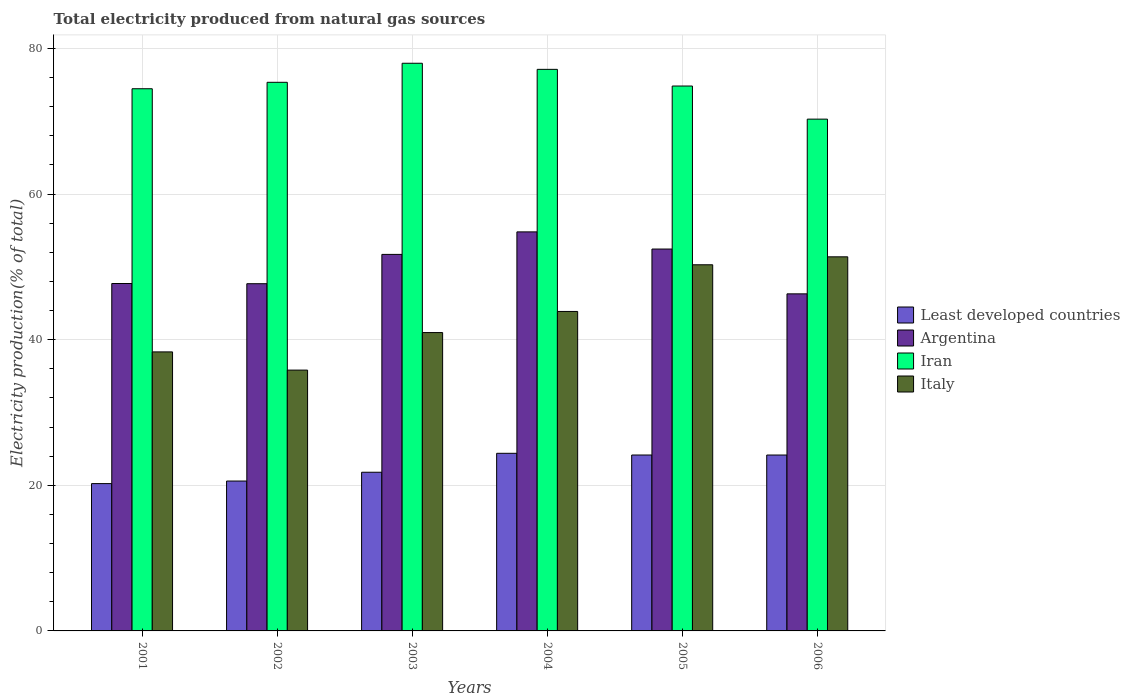How many different coloured bars are there?
Your answer should be very brief. 4. How many groups of bars are there?
Your answer should be compact. 6. What is the label of the 6th group of bars from the left?
Offer a very short reply. 2006. In how many cases, is the number of bars for a given year not equal to the number of legend labels?
Offer a very short reply. 0. What is the total electricity produced in Iran in 2003?
Provide a short and direct response. 77.96. Across all years, what is the maximum total electricity produced in Iran?
Offer a terse response. 77.96. Across all years, what is the minimum total electricity produced in Italy?
Your answer should be very brief. 35.82. In which year was the total electricity produced in Italy maximum?
Offer a terse response. 2006. What is the total total electricity produced in Argentina in the graph?
Offer a very short reply. 300.64. What is the difference between the total electricity produced in Argentina in 2002 and that in 2004?
Provide a short and direct response. -7.12. What is the difference between the total electricity produced in Least developed countries in 2005 and the total electricity produced in Iran in 2004?
Your response must be concise. -52.97. What is the average total electricity produced in Iran per year?
Ensure brevity in your answer.  75. In the year 2005, what is the difference between the total electricity produced in Italy and total electricity produced in Iran?
Offer a very short reply. -24.55. In how many years, is the total electricity produced in Iran greater than 64 %?
Your answer should be very brief. 6. What is the ratio of the total electricity produced in Argentina in 2003 to that in 2004?
Offer a terse response. 0.94. Is the total electricity produced in Least developed countries in 2002 less than that in 2005?
Make the answer very short. Yes. What is the difference between the highest and the second highest total electricity produced in Least developed countries?
Offer a very short reply. 0.23. What is the difference between the highest and the lowest total electricity produced in Argentina?
Give a very brief answer. 8.51. What does the 2nd bar from the left in 2002 represents?
Your answer should be compact. Argentina. What does the 4th bar from the right in 2006 represents?
Provide a succinct answer. Least developed countries. Is it the case that in every year, the sum of the total electricity produced in Argentina and total electricity produced in Italy is greater than the total electricity produced in Iran?
Offer a terse response. Yes. How many years are there in the graph?
Ensure brevity in your answer.  6. Are the values on the major ticks of Y-axis written in scientific E-notation?
Your response must be concise. No. Where does the legend appear in the graph?
Provide a succinct answer. Center right. What is the title of the graph?
Ensure brevity in your answer.  Total electricity produced from natural gas sources. Does "Benin" appear as one of the legend labels in the graph?
Keep it short and to the point. No. What is the Electricity production(% of total) in Least developed countries in 2001?
Your response must be concise. 20.23. What is the Electricity production(% of total) of Argentina in 2001?
Your response must be concise. 47.71. What is the Electricity production(% of total) of Iran in 2001?
Make the answer very short. 74.46. What is the Electricity production(% of total) in Italy in 2001?
Keep it short and to the point. 38.32. What is the Electricity production(% of total) in Least developed countries in 2002?
Make the answer very short. 20.58. What is the Electricity production(% of total) in Argentina in 2002?
Offer a very short reply. 47.68. What is the Electricity production(% of total) in Iran in 2002?
Your answer should be very brief. 75.34. What is the Electricity production(% of total) in Italy in 2002?
Make the answer very short. 35.82. What is the Electricity production(% of total) in Least developed countries in 2003?
Provide a short and direct response. 21.79. What is the Electricity production(% of total) in Argentina in 2003?
Provide a succinct answer. 51.71. What is the Electricity production(% of total) in Iran in 2003?
Provide a succinct answer. 77.96. What is the Electricity production(% of total) in Italy in 2003?
Your response must be concise. 40.97. What is the Electricity production(% of total) of Least developed countries in 2004?
Your answer should be compact. 24.39. What is the Electricity production(% of total) in Argentina in 2004?
Offer a terse response. 54.8. What is the Electricity production(% of total) of Iran in 2004?
Make the answer very short. 77.12. What is the Electricity production(% of total) in Italy in 2004?
Make the answer very short. 43.87. What is the Electricity production(% of total) in Least developed countries in 2005?
Offer a very short reply. 24.16. What is the Electricity production(% of total) in Argentina in 2005?
Provide a succinct answer. 52.45. What is the Electricity production(% of total) in Iran in 2005?
Ensure brevity in your answer.  74.83. What is the Electricity production(% of total) of Italy in 2005?
Offer a terse response. 50.28. What is the Electricity production(% of total) of Least developed countries in 2006?
Your response must be concise. 24.16. What is the Electricity production(% of total) in Argentina in 2006?
Provide a succinct answer. 46.29. What is the Electricity production(% of total) of Iran in 2006?
Offer a very short reply. 70.29. What is the Electricity production(% of total) in Italy in 2006?
Provide a short and direct response. 51.38. Across all years, what is the maximum Electricity production(% of total) of Least developed countries?
Provide a short and direct response. 24.39. Across all years, what is the maximum Electricity production(% of total) in Argentina?
Provide a short and direct response. 54.8. Across all years, what is the maximum Electricity production(% of total) of Iran?
Keep it short and to the point. 77.96. Across all years, what is the maximum Electricity production(% of total) of Italy?
Make the answer very short. 51.38. Across all years, what is the minimum Electricity production(% of total) in Least developed countries?
Your response must be concise. 20.23. Across all years, what is the minimum Electricity production(% of total) in Argentina?
Ensure brevity in your answer.  46.29. Across all years, what is the minimum Electricity production(% of total) of Iran?
Give a very brief answer. 70.29. Across all years, what is the minimum Electricity production(% of total) of Italy?
Your answer should be compact. 35.82. What is the total Electricity production(% of total) in Least developed countries in the graph?
Ensure brevity in your answer.  135.31. What is the total Electricity production(% of total) in Argentina in the graph?
Provide a succinct answer. 300.64. What is the total Electricity production(% of total) in Iran in the graph?
Make the answer very short. 450. What is the total Electricity production(% of total) of Italy in the graph?
Keep it short and to the point. 260.65. What is the difference between the Electricity production(% of total) in Least developed countries in 2001 and that in 2002?
Your answer should be very brief. -0.35. What is the difference between the Electricity production(% of total) in Argentina in 2001 and that in 2002?
Your response must be concise. 0.03. What is the difference between the Electricity production(% of total) in Iran in 2001 and that in 2002?
Offer a terse response. -0.88. What is the difference between the Electricity production(% of total) in Italy in 2001 and that in 2002?
Your response must be concise. 2.5. What is the difference between the Electricity production(% of total) in Least developed countries in 2001 and that in 2003?
Offer a very short reply. -1.56. What is the difference between the Electricity production(% of total) in Argentina in 2001 and that in 2003?
Make the answer very short. -4. What is the difference between the Electricity production(% of total) in Iran in 2001 and that in 2003?
Your response must be concise. -3.5. What is the difference between the Electricity production(% of total) of Italy in 2001 and that in 2003?
Give a very brief answer. -2.65. What is the difference between the Electricity production(% of total) of Least developed countries in 2001 and that in 2004?
Keep it short and to the point. -4.16. What is the difference between the Electricity production(% of total) in Argentina in 2001 and that in 2004?
Provide a succinct answer. -7.09. What is the difference between the Electricity production(% of total) in Iran in 2001 and that in 2004?
Ensure brevity in your answer.  -2.66. What is the difference between the Electricity production(% of total) in Italy in 2001 and that in 2004?
Provide a succinct answer. -5.56. What is the difference between the Electricity production(% of total) in Least developed countries in 2001 and that in 2005?
Give a very brief answer. -3.93. What is the difference between the Electricity production(% of total) in Argentina in 2001 and that in 2005?
Offer a very short reply. -4.73. What is the difference between the Electricity production(% of total) of Iran in 2001 and that in 2005?
Your answer should be very brief. -0.37. What is the difference between the Electricity production(% of total) of Italy in 2001 and that in 2005?
Offer a terse response. -11.96. What is the difference between the Electricity production(% of total) of Least developed countries in 2001 and that in 2006?
Offer a terse response. -3.93. What is the difference between the Electricity production(% of total) in Argentina in 2001 and that in 2006?
Keep it short and to the point. 1.42. What is the difference between the Electricity production(% of total) of Iran in 2001 and that in 2006?
Your answer should be very brief. 4.17. What is the difference between the Electricity production(% of total) in Italy in 2001 and that in 2006?
Make the answer very short. -13.06. What is the difference between the Electricity production(% of total) of Least developed countries in 2002 and that in 2003?
Make the answer very short. -1.21. What is the difference between the Electricity production(% of total) in Argentina in 2002 and that in 2003?
Give a very brief answer. -4.03. What is the difference between the Electricity production(% of total) in Iran in 2002 and that in 2003?
Your answer should be compact. -2.62. What is the difference between the Electricity production(% of total) in Italy in 2002 and that in 2003?
Your answer should be compact. -5.15. What is the difference between the Electricity production(% of total) of Least developed countries in 2002 and that in 2004?
Provide a short and direct response. -3.81. What is the difference between the Electricity production(% of total) of Argentina in 2002 and that in 2004?
Provide a short and direct response. -7.12. What is the difference between the Electricity production(% of total) of Iran in 2002 and that in 2004?
Your answer should be very brief. -1.78. What is the difference between the Electricity production(% of total) in Italy in 2002 and that in 2004?
Make the answer very short. -8.05. What is the difference between the Electricity production(% of total) in Least developed countries in 2002 and that in 2005?
Provide a short and direct response. -3.57. What is the difference between the Electricity production(% of total) in Argentina in 2002 and that in 2005?
Keep it short and to the point. -4.76. What is the difference between the Electricity production(% of total) of Iran in 2002 and that in 2005?
Give a very brief answer. 0.51. What is the difference between the Electricity production(% of total) of Italy in 2002 and that in 2005?
Your answer should be very brief. -14.46. What is the difference between the Electricity production(% of total) of Least developed countries in 2002 and that in 2006?
Give a very brief answer. -3.57. What is the difference between the Electricity production(% of total) in Argentina in 2002 and that in 2006?
Keep it short and to the point. 1.39. What is the difference between the Electricity production(% of total) of Iran in 2002 and that in 2006?
Provide a short and direct response. 5.06. What is the difference between the Electricity production(% of total) in Italy in 2002 and that in 2006?
Your response must be concise. -15.56. What is the difference between the Electricity production(% of total) of Least developed countries in 2003 and that in 2004?
Make the answer very short. -2.6. What is the difference between the Electricity production(% of total) in Argentina in 2003 and that in 2004?
Keep it short and to the point. -3.09. What is the difference between the Electricity production(% of total) in Iran in 2003 and that in 2004?
Your answer should be compact. 0.84. What is the difference between the Electricity production(% of total) of Italy in 2003 and that in 2004?
Offer a very short reply. -2.9. What is the difference between the Electricity production(% of total) in Least developed countries in 2003 and that in 2005?
Offer a terse response. -2.37. What is the difference between the Electricity production(% of total) of Argentina in 2003 and that in 2005?
Your answer should be compact. -0.74. What is the difference between the Electricity production(% of total) in Iran in 2003 and that in 2005?
Your answer should be very brief. 3.13. What is the difference between the Electricity production(% of total) in Italy in 2003 and that in 2005?
Your response must be concise. -9.31. What is the difference between the Electricity production(% of total) of Least developed countries in 2003 and that in 2006?
Provide a succinct answer. -2.37. What is the difference between the Electricity production(% of total) of Argentina in 2003 and that in 2006?
Provide a succinct answer. 5.42. What is the difference between the Electricity production(% of total) of Iran in 2003 and that in 2006?
Offer a very short reply. 7.67. What is the difference between the Electricity production(% of total) in Italy in 2003 and that in 2006?
Provide a succinct answer. -10.4. What is the difference between the Electricity production(% of total) in Least developed countries in 2004 and that in 2005?
Your response must be concise. 0.23. What is the difference between the Electricity production(% of total) in Argentina in 2004 and that in 2005?
Keep it short and to the point. 2.36. What is the difference between the Electricity production(% of total) of Iran in 2004 and that in 2005?
Provide a succinct answer. 2.29. What is the difference between the Electricity production(% of total) of Italy in 2004 and that in 2005?
Provide a short and direct response. -6.41. What is the difference between the Electricity production(% of total) in Least developed countries in 2004 and that in 2006?
Offer a terse response. 0.24. What is the difference between the Electricity production(% of total) of Argentina in 2004 and that in 2006?
Offer a terse response. 8.51. What is the difference between the Electricity production(% of total) of Iran in 2004 and that in 2006?
Your response must be concise. 6.84. What is the difference between the Electricity production(% of total) in Italy in 2004 and that in 2006?
Make the answer very short. -7.5. What is the difference between the Electricity production(% of total) in Least developed countries in 2005 and that in 2006?
Provide a succinct answer. 0. What is the difference between the Electricity production(% of total) of Argentina in 2005 and that in 2006?
Your response must be concise. 6.16. What is the difference between the Electricity production(% of total) in Iran in 2005 and that in 2006?
Your answer should be compact. 4.55. What is the difference between the Electricity production(% of total) in Italy in 2005 and that in 2006?
Give a very brief answer. -1.09. What is the difference between the Electricity production(% of total) in Least developed countries in 2001 and the Electricity production(% of total) in Argentina in 2002?
Your answer should be compact. -27.45. What is the difference between the Electricity production(% of total) of Least developed countries in 2001 and the Electricity production(% of total) of Iran in 2002?
Ensure brevity in your answer.  -55.11. What is the difference between the Electricity production(% of total) of Least developed countries in 2001 and the Electricity production(% of total) of Italy in 2002?
Make the answer very short. -15.59. What is the difference between the Electricity production(% of total) in Argentina in 2001 and the Electricity production(% of total) in Iran in 2002?
Your answer should be very brief. -27.63. What is the difference between the Electricity production(% of total) of Argentina in 2001 and the Electricity production(% of total) of Italy in 2002?
Your answer should be compact. 11.89. What is the difference between the Electricity production(% of total) in Iran in 2001 and the Electricity production(% of total) in Italy in 2002?
Provide a succinct answer. 38.64. What is the difference between the Electricity production(% of total) in Least developed countries in 2001 and the Electricity production(% of total) in Argentina in 2003?
Make the answer very short. -31.48. What is the difference between the Electricity production(% of total) of Least developed countries in 2001 and the Electricity production(% of total) of Iran in 2003?
Provide a succinct answer. -57.73. What is the difference between the Electricity production(% of total) in Least developed countries in 2001 and the Electricity production(% of total) in Italy in 2003?
Ensure brevity in your answer.  -20.74. What is the difference between the Electricity production(% of total) in Argentina in 2001 and the Electricity production(% of total) in Iran in 2003?
Ensure brevity in your answer.  -30.25. What is the difference between the Electricity production(% of total) of Argentina in 2001 and the Electricity production(% of total) of Italy in 2003?
Offer a terse response. 6.74. What is the difference between the Electricity production(% of total) in Iran in 2001 and the Electricity production(% of total) in Italy in 2003?
Make the answer very short. 33.49. What is the difference between the Electricity production(% of total) of Least developed countries in 2001 and the Electricity production(% of total) of Argentina in 2004?
Provide a succinct answer. -34.57. What is the difference between the Electricity production(% of total) in Least developed countries in 2001 and the Electricity production(% of total) in Iran in 2004?
Offer a terse response. -56.89. What is the difference between the Electricity production(% of total) of Least developed countries in 2001 and the Electricity production(% of total) of Italy in 2004?
Your response must be concise. -23.64. What is the difference between the Electricity production(% of total) of Argentina in 2001 and the Electricity production(% of total) of Iran in 2004?
Keep it short and to the point. -29.41. What is the difference between the Electricity production(% of total) in Argentina in 2001 and the Electricity production(% of total) in Italy in 2004?
Your answer should be very brief. 3.84. What is the difference between the Electricity production(% of total) in Iran in 2001 and the Electricity production(% of total) in Italy in 2004?
Provide a short and direct response. 30.58. What is the difference between the Electricity production(% of total) in Least developed countries in 2001 and the Electricity production(% of total) in Argentina in 2005?
Provide a short and direct response. -32.21. What is the difference between the Electricity production(% of total) of Least developed countries in 2001 and the Electricity production(% of total) of Iran in 2005?
Your answer should be compact. -54.6. What is the difference between the Electricity production(% of total) in Least developed countries in 2001 and the Electricity production(% of total) in Italy in 2005?
Offer a terse response. -30.05. What is the difference between the Electricity production(% of total) of Argentina in 2001 and the Electricity production(% of total) of Iran in 2005?
Your answer should be very brief. -27.12. What is the difference between the Electricity production(% of total) in Argentina in 2001 and the Electricity production(% of total) in Italy in 2005?
Offer a terse response. -2.57. What is the difference between the Electricity production(% of total) in Iran in 2001 and the Electricity production(% of total) in Italy in 2005?
Make the answer very short. 24.18. What is the difference between the Electricity production(% of total) in Least developed countries in 2001 and the Electricity production(% of total) in Argentina in 2006?
Offer a very short reply. -26.06. What is the difference between the Electricity production(% of total) of Least developed countries in 2001 and the Electricity production(% of total) of Iran in 2006?
Your answer should be very brief. -50.05. What is the difference between the Electricity production(% of total) of Least developed countries in 2001 and the Electricity production(% of total) of Italy in 2006?
Offer a very short reply. -31.14. What is the difference between the Electricity production(% of total) in Argentina in 2001 and the Electricity production(% of total) in Iran in 2006?
Offer a terse response. -22.57. What is the difference between the Electricity production(% of total) of Argentina in 2001 and the Electricity production(% of total) of Italy in 2006?
Give a very brief answer. -3.66. What is the difference between the Electricity production(% of total) of Iran in 2001 and the Electricity production(% of total) of Italy in 2006?
Keep it short and to the point. 23.08. What is the difference between the Electricity production(% of total) of Least developed countries in 2002 and the Electricity production(% of total) of Argentina in 2003?
Provide a succinct answer. -31.13. What is the difference between the Electricity production(% of total) in Least developed countries in 2002 and the Electricity production(% of total) in Iran in 2003?
Your answer should be compact. -57.38. What is the difference between the Electricity production(% of total) in Least developed countries in 2002 and the Electricity production(% of total) in Italy in 2003?
Offer a terse response. -20.39. What is the difference between the Electricity production(% of total) of Argentina in 2002 and the Electricity production(% of total) of Iran in 2003?
Offer a very short reply. -30.28. What is the difference between the Electricity production(% of total) of Argentina in 2002 and the Electricity production(% of total) of Italy in 2003?
Your answer should be very brief. 6.71. What is the difference between the Electricity production(% of total) of Iran in 2002 and the Electricity production(% of total) of Italy in 2003?
Provide a short and direct response. 34.37. What is the difference between the Electricity production(% of total) in Least developed countries in 2002 and the Electricity production(% of total) in Argentina in 2004?
Provide a short and direct response. -34.22. What is the difference between the Electricity production(% of total) of Least developed countries in 2002 and the Electricity production(% of total) of Iran in 2004?
Your answer should be compact. -56.54. What is the difference between the Electricity production(% of total) in Least developed countries in 2002 and the Electricity production(% of total) in Italy in 2004?
Offer a terse response. -23.29. What is the difference between the Electricity production(% of total) of Argentina in 2002 and the Electricity production(% of total) of Iran in 2004?
Make the answer very short. -29.44. What is the difference between the Electricity production(% of total) of Argentina in 2002 and the Electricity production(% of total) of Italy in 2004?
Ensure brevity in your answer.  3.81. What is the difference between the Electricity production(% of total) in Iran in 2002 and the Electricity production(% of total) in Italy in 2004?
Your answer should be compact. 31.47. What is the difference between the Electricity production(% of total) of Least developed countries in 2002 and the Electricity production(% of total) of Argentina in 2005?
Offer a very short reply. -31.86. What is the difference between the Electricity production(% of total) in Least developed countries in 2002 and the Electricity production(% of total) in Iran in 2005?
Offer a terse response. -54.25. What is the difference between the Electricity production(% of total) of Least developed countries in 2002 and the Electricity production(% of total) of Italy in 2005?
Provide a succinct answer. -29.7. What is the difference between the Electricity production(% of total) in Argentina in 2002 and the Electricity production(% of total) in Iran in 2005?
Offer a very short reply. -27.15. What is the difference between the Electricity production(% of total) in Argentina in 2002 and the Electricity production(% of total) in Italy in 2005?
Provide a succinct answer. -2.6. What is the difference between the Electricity production(% of total) of Iran in 2002 and the Electricity production(% of total) of Italy in 2005?
Ensure brevity in your answer.  25.06. What is the difference between the Electricity production(% of total) in Least developed countries in 2002 and the Electricity production(% of total) in Argentina in 2006?
Provide a succinct answer. -25.71. What is the difference between the Electricity production(% of total) of Least developed countries in 2002 and the Electricity production(% of total) of Iran in 2006?
Provide a short and direct response. -49.7. What is the difference between the Electricity production(% of total) of Least developed countries in 2002 and the Electricity production(% of total) of Italy in 2006?
Your answer should be compact. -30.79. What is the difference between the Electricity production(% of total) in Argentina in 2002 and the Electricity production(% of total) in Iran in 2006?
Give a very brief answer. -22.6. What is the difference between the Electricity production(% of total) in Argentina in 2002 and the Electricity production(% of total) in Italy in 2006?
Your response must be concise. -3.69. What is the difference between the Electricity production(% of total) of Iran in 2002 and the Electricity production(% of total) of Italy in 2006?
Keep it short and to the point. 23.97. What is the difference between the Electricity production(% of total) of Least developed countries in 2003 and the Electricity production(% of total) of Argentina in 2004?
Offer a terse response. -33.01. What is the difference between the Electricity production(% of total) of Least developed countries in 2003 and the Electricity production(% of total) of Iran in 2004?
Make the answer very short. -55.33. What is the difference between the Electricity production(% of total) in Least developed countries in 2003 and the Electricity production(% of total) in Italy in 2004?
Your response must be concise. -22.08. What is the difference between the Electricity production(% of total) of Argentina in 2003 and the Electricity production(% of total) of Iran in 2004?
Offer a terse response. -25.41. What is the difference between the Electricity production(% of total) in Argentina in 2003 and the Electricity production(% of total) in Italy in 2004?
Your answer should be very brief. 7.84. What is the difference between the Electricity production(% of total) in Iran in 2003 and the Electricity production(% of total) in Italy in 2004?
Provide a succinct answer. 34.08. What is the difference between the Electricity production(% of total) in Least developed countries in 2003 and the Electricity production(% of total) in Argentina in 2005?
Provide a short and direct response. -30.65. What is the difference between the Electricity production(% of total) of Least developed countries in 2003 and the Electricity production(% of total) of Iran in 2005?
Offer a very short reply. -53.04. What is the difference between the Electricity production(% of total) in Least developed countries in 2003 and the Electricity production(% of total) in Italy in 2005?
Give a very brief answer. -28.49. What is the difference between the Electricity production(% of total) of Argentina in 2003 and the Electricity production(% of total) of Iran in 2005?
Keep it short and to the point. -23.12. What is the difference between the Electricity production(% of total) of Argentina in 2003 and the Electricity production(% of total) of Italy in 2005?
Your answer should be compact. 1.43. What is the difference between the Electricity production(% of total) of Iran in 2003 and the Electricity production(% of total) of Italy in 2005?
Ensure brevity in your answer.  27.68. What is the difference between the Electricity production(% of total) in Least developed countries in 2003 and the Electricity production(% of total) in Argentina in 2006?
Your answer should be very brief. -24.5. What is the difference between the Electricity production(% of total) of Least developed countries in 2003 and the Electricity production(% of total) of Iran in 2006?
Provide a succinct answer. -48.49. What is the difference between the Electricity production(% of total) in Least developed countries in 2003 and the Electricity production(% of total) in Italy in 2006?
Provide a short and direct response. -29.58. What is the difference between the Electricity production(% of total) of Argentina in 2003 and the Electricity production(% of total) of Iran in 2006?
Provide a succinct answer. -18.58. What is the difference between the Electricity production(% of total) of Argentina in 2003 and the Electricity production(% of total) of Italy in 2006?
Offer a very short reply. 0.33. What is the difference between the Electricity production(% of total) in Iran in 2003 and the Electricity production(% of total) in Italy in 2006?
Your response must be concise. 26.58. What is the difference between the Electricity production(% of total) of Least developed countries in 2004 and the Electricity production(% of total) of Argentina in 2005?
Keep it short and to the point. -28.05. What is the difference between the Electricity production(% of total) of Least developed countries in 2004 and the Electricity production(% of total) of Iran in 2005?
Make the answer very short. -50.44. What is the difference between the Electricity production(% of total) in Least developed countries in 2004 and the Electricity production(% of total) in Italy in 2005?
Keep it short and to the point. -25.89. What is the difference between the Electricity production(% of total) of Argentina in 2004 and the Electricity production(% of total) of Iran in 2005?
Provide a succinct answer. -20.03. What is the difference between the Electricity production(% of total) in Argentina in 2004 and the Electricity production(% of total) in Italy in 2005?
Provide a short and direct response. 4.52. What is the difference between the Electricity production(% of total) in Iran in 2004 and the Electricity production(% of total) in Italy in 2005?
Offer a very short reply. 26.84. What is the difference between the Electricity production(% of total) of Least developed countries in 2004 and the Electricity production(% of total) of Argentina in 2006?
Ensure brevity in your answer.  -21.9. What is the difference between the Electricity production(% of total) of Least developed countries in 2004 and the Electricity production(% of total) of Iran in 2006?
Provide a succinct answer. -45.89. What is the difference between the Electricity production(% of total) of Least developed countries in 2004 and the Electricity production(% of total) of Italy in 2006?
Provide a short and direct response. -26.98. What is the difference between the Electricity production(% of total) in Argentina in 2004 and the Electricity production(% of total) in Iran in 2006?
Offer a very short reply. -15.48. What is the difference between the Electricity production(% of total) of Argentina in 2004 and the Electricity production(% of total) of Italy in 2006?
Your answer should be very brief. 3.43. What is the difference between the Electricity production(% of total) in Iran in 2004 and the Electricity production(% of total) in Italy in 2006?
Offer a very short reply. 25.75. What is the difference between the Electricity production(% of total) in Least developed countries in 2005 and the Electricity production(% of total) in Argentina in 2006?
Offer a terse response. -22.13. What is the difference between the Electricity production(% of total) of Least developed countries in 2005 and the Electricity production(% of total) of Iran in 2006?
Keep it short and to the point. -46.13. What is the difference between the Electricity production(% of total) of Least developed countries in 2005 and the Electricity production(% of total) of Italy in 2006?
Your response must be concise. -27.22. What is the difference between the Electricity production(% of total) of Argentina in 2005 and the Electricity production(% of total) of Iran in 2006?
Give a very brief answer. -17.84. What is the difference between the Electricity production(% of total) of Argentina in 2005 and the Electricity production(% of total) of Italy in 2006?
Keep it short and to the point. 1.07. What is the difference between the Electricity production(% of total) in Iran in 2005 and the Electricity production(% of total) in Italy in 2006?
Make the answer very short. 23.46. What is the average Electricity production(% of total) of Least developed countries per year?
Offer a terse response. 22.55. What is the average Electricity production(% of total) of Argentina per year?
Your response must be concise. 50.11. What is the average Electricity production(% of total) of Iran per year?
Your response must be concise. 75. What is the average Electricity production(% of total) of Italy per year?
Provide a short and direct response. 43.44. In the year 2001, what is the difference between the Electricity production(% of total) in Least developed countries and Electricity production(% of total) in Argentina?
Give a very brief answer. -27.48. In the year 2001, what is the difference between the Electricity production(% of total) of Least developed countries and Electricity production(% of total) of Iran?
Provide a succinct answer. -54.23. In the year 2001, what is the difference between the Electricity production(% of total) in Least developed countries and Electricity production(% of total) in Italy?
Ensure brevity in your answer.  -18.09. In the year 2001, what is the difference between the Electricity production(% of total) in Argentina and Electricity production(% of total) in Iran?
Keep it short and to the point. -26.75. In the year 2001, what is the difference between the Electricity production(% of total) of Argentina and Electricity production(% of total) of Italy?
Offer a terse response. 9.39. In the year 2001, what is the difference between the Electricity production(% of total) in Iran and Electricity production(% of total) in Italy?
Keep it short and to the point. 36.14. In the year 2002, what is the difference between the Electricity production(% of total) in Least developed countries and Electricity production(% of total) in Argentina?
Give a very brief answer. -27.1. In the year 2002, what is the difference between the Electricity production(% of total) in Least developed countries and Electricity production(% of total) in Iran?
Offer a terse response. -54.76. In the year 2002, what is the difference between the Electricity production(% of total) of Least developed countries and Electricity production(% of total) of Italy?
Provide a short and direct response. -15.24. In the year 2002, what is the difference between the Electricity production(% of total) in Argentina and Electricity production(% of total) in Iran?
Make the answer very short. -27.66. In the year 2002, what is the difference between the Electricity production(% of total) of Argentina and Electricity production(% of total) of Italy?
Provide a succinct answer. 11.86. In the year 2002, what is the difference between the Electricity production(% of total) in Iran and Electricity production(% of total) in Italy?
Offer a terse response. 39.52. In the year 2003, what is the difference between the Electricity production(% of total) in Least developed countries and Electricity production(% of total) in Argentina?
Provide a short and direct response. -29.92. In the year 2003, what is the difference between the Electricity production(% of total) in Least developed countries and Electricity production(% of total) in Iran?
Provide a short and direct response. -56.17. In the year 2003, what is the difference between the Electricity production(% of total) in Least developed countries and Electricity production(% of total) in Italy?
Offer a terse response. -19.18. In the year 2003, what is the difference between the Electricity production(% of total) in Argentina and Electricity production(% of total) in Iran?
Your answer should be compact. -26.25. In the year 2003, what is the difference between the Electricity production(% of total) of Argentina and Electricity production(% of total) of Italy?
Keep it short and to the point. 10.74. In the year 2003, what is the difference between the Electricity production(% of total) of Iran and Electricity production(% of total) of Italy?
Ensure brevity in your answer.  36.99. In the year 2004, what is the difference between the Electricity production(% of total) of Least developed countries and Electricity production(% of total) of Argentina?
Offer a very short reply. -30.41. In the year 2004, what is the difference between the Electricity production(% of total) in Least developed countries and Electricity production(% of total) in Iran?
Your answer should be compact. -52.73. In the year 2004, what is the difference between the Electricity production(% of total) of Least developed countries and Electricity production(% of total) of Italy?
Provide a short and direct response. -19.48. In the year 2004, what is the difference between the Electricity production(% of total) in Argentina and Electricity production(% of total) in Iran?
Ensure brevity in your answer.  -22.32. In the year 2004, what is the difference between the Electricity production(% of total) of Argentina and Electricity production(% of total) of Italy?
Offer a very short reply. 10.93. In the year 2004, what is the difference between the Electricity production(% of total) in Iran and Electricity production(% of total) in Italy?
Provide a succinct answer. 33.25. In the year 2005, what is the difference between the Electricity production(% of total) of Least developed countries and Electricity production(% of total) of Argentina?
Keep it short and to the point. -28.29. In the year 2005, what is the difference between the Electricity production(% of total) of Least developed countries and Electricity production(% of total) of Iran?
Make the answer very short. -50.67. In the year 2005, what is the difference between the Electricity production(% of total) in Least developed countries and Electricity production(% of total) in Italy?
Offer a terse response. -26.13. In the year 2005, what is the difference between the Electricity production(% of total) in Argentina and Electricity production(% of total) in Iran?
Your answer should be very brief. -22.39. In the year 2005, what is the difference between the Electricity production(% of total) of Argentina and Electricity production(% of total) of Italy?
Ensure brevity in your answer.  2.16. In the year 2005, what is the difference between the Electricity production(% of total) of Iran and Electricity production(% of total) of Italy?
Provide a succinct answer. 24.55. In the year 2006, what is the difference between the Electricity production(% of total) in Least developed countries and Electricity production(% of total) in Argentina?
Your response must be concise. -22.13. In the year 2006, what is the difference between the Electricity production(% of total) in Least developed countries and Electricity production(% of total) in Iran?
Ensure brevity in your answer.  -46.13. In the year 2006, what is the difference between the Electricity production(% of total) of Least developed countries and Electricity production(% of total) of Italy?
Your answer should be compact. -27.22. In the year 2006, what is the difference between the Electricity production(% of total) in Argentina and Electricity production(% of total) in Iran?
Offer a terse response. -24. In the year 2006, what is the difference between the Electricity production(% of total) in Argentina and Electricity production(% of total) in Italy?
Offer a very short reply. -5.09. In the year 2006, what is the difference between the Electricity production(% of total) of Iran and Electricity production(% of total) of Italy?
Your response must be concise. 18.91. What is the ratio of the Electricity production(% of total) of Least developed countries in 2001 to that in 2002?
Keep it short and to the point. 0.98. What is the ratio of the Electricity production(% of total) in Argentina in 2001 to that in 2002?
Your answer should be very brief. 1. What is the ratio of the Electricity production(% of total) in Iran in 2001 to that in 2002?
Your answer should be very brief. 0.99. What is the ratio of the Electricity production(% of total) in Italy in 2001 to that in 2002?
Make the answer very short. 1.07. What is the ratio of the Electricity production(% of total) in Least developed countries in 2001 to that in 2003?
Give a very brief answer. 0.93. What is the ratio of the Electricity production(% of total) of Argentina in 2001 to that in 2003?
Provide a short and direct response. 0.92. What is the ratio of the Electricity production(% of total) of Iran in 2001 to that in 2003?
Your answer should be very brief. 0.96. What is the ratio of the Electricity production(% of total) of Italy in 2001 to that in 2003?
Provide a short and direct response. 0.94. What is the ratio of the Electricity production(% of total) of Least developed countries in 2001 to that in 2004?
Give a very brief answer. 0.83. What is the ratio of the Electricity production(% of total) of Argentina in 2001 to that in 2004?
Make the answer very short. 0.87. What is the ratio of the Electricity production(% of total) in Iran in 2001 to that in 2004?
Offer a very short reply. 0.97. What is the ratio of the Electricity production(% of total) of Italy in 2001 to that in 2004?
Offer a very short reply. 0.87. What is the ratio of the Electricity production(% of total) of Least developed countries in 2001 to that in 2005?
Ensure brevity in your answer.  0.84. What is the ratio of the Electricity production(% of total) in Argentina in 2001 to that in 2005?
Your response must be concise. 0.91. What is the ratio of the Electricity production(% of total) of Iran in 2001 to that in 2005?
Ensure brevity in your answer.  0.99. What is the ratio of the Electricity production(% of total) in Italy in 2001 to that in 2005?
Your response must be concise. 0.76. What is the ratio of the Electricity production(% of total) in Least developed countries in 2001 to that in 2006?
Provide a short and direct response. 0.84. What is the ratio of the Electricity production(% of total) of Argentina in 2001 to that in 2006?
Offer a terse response. 1.03. What is the ratio of the Electricity production(% of total) of Iran in 2001 to that in 2006?
Offer a terse response. 1.06. What is the ratio of the Electricity production(% of total) of Italy in 2001 to that in 2006?
Keep it short and to the point. 0.75. What is the ratio of the Electricity production(% of total) of Least developed countries in 2002 to that in 2003?
Your answer should be compact. 0.94. What is the ratio of the Electricity production(% of total) in Argentina in 2002 to that in 2003?
Keep it short and to the point. 0.92. What is the ratio of the Electricity production(% of total) in Iran in 2002 to that in 2003?
Your answer should be very brief. 0.97. What is the ratio of the Electricity production(% of total) of Italy in 2002 to that in 2003?
Your answer should be very brief. 0.87. What is the ratio of the Electricity production(% of total) of Least developed countries in 2002 to that in 2004?
Your answer should be very brief. 0.84. What is the ratio of the Electricity production(% of total) of Argentina in 2002 to that in 2004?
Your answer should be compact. 0.87. What is the ratio of the Electricity production(% of total) in Iran in 2002 to that in 2004?
Provide a succinct answer. 0.98. What is the ratio of the Electricity production(% of total) in Italy in 2002 to that in 2004?
Your answer should be compact. 0.82. What is the ratio of the Electricity production(% of total) of Least developed countries in 2002 to that in 2005?
Give a very brief answer. 0.85. What is the ratio of the Electricity production(% of total) in Argentina in 2002 to that in 2005?
Keep it short and to the point. 0.91. What is the ratio of the Electricity production(% of total) in Iran in 2002 to that in 2005?
Offer a very short reply. 1.01. What is the ratio of the Electricity production(% of total) of Italy in 2002 to that in 2005?
Your response must be concise. 0.71. What is the ratio of the Electricity production(% of total) in Least developed countries in 2002 to that in 2006?
Offer a terse response. 0.85. What is the ratio of the Electricity production(% of total) of Argentina in 2002 to that in 2006?
Give a very brief answer. 1.03. What is the ratio of the Electricity production(% of total) in Iran in 2002 to that in 2006?
Provide a short and direct response. 1.07. What is the ratio of the Electricity production(% of total) in Italy in 2002 to that in 2006?
Ensure brevity in your answer.  0.7. What is the ratio of the Electricity production(% of total) in Least developed countries in 2003 to that in 2004?
Make the answer very short. 0.89. What is the ratio of the Electricity production(% of total) in Argentina in 2003 to that in 2004?
Your response must be concise. 0.94. What is the ratio of the Electricity production(% of total) in Iran in 2003 to that in 2004?
Make the answer very short. 1.01. What is the ratio of the Electricity production(% of total) of Italy in 2003 to that in 2004?
Your answer should be very brief. 0.93. What is the ratio of the Electricity production(% of total) in Least developed countries in 2003 to that in 2005?
Make the answer very short. 0.9. What is the ratio of the Electricity production(% of total) in Argentina in 2003 to that in 2005?
Keep it short and to the point. 0.99. What is the ratio of the Electricity production(% of total) of Iran in 2003 to that in 2005?
Keep it short and to the point. 1.04. What is the ratio of the Electricity production(% of total) in Italy in 2003 to that in 2005?
Your answer should be compact. 0.81. What is the ratio of the Electricity production(% of total) of Least developed countries in 2003 to that in 2006?
Give a very brief answer. 0.9. What is the ratio of the Electricity production(% of total) in Argentina in 2003 to that in 2006?
Your answer should be very brief. 1.12. What is the ratio of the Electricity production(% of total) of Iran in 2003 to that in 2006?
Give a very brief answer. 1.11. What is the ratio of the Electricity production(% of total) in Italy in 2003 to that in 2006?
Make the answer very short. 0.8. What is the ratio of the Electricity production(% of total) in Least developed countries in 2004 to that in 2005?
Give a very brief answer. 1.01. What is the ratio of the Electricity production(% of total) of Argentina in 2004 to that in 2005?
Your answer should be compact. 1.04. What is the ratio of the Electricity production(% of total) in Iran in 2004 to that in 2005?
Give a very brief answer. 1.03. What is the ratio of the Electricity production(% of total) of Italy in 2004 to that in 2005?
Offer a very short reply. 0.87. What is the ratio of the Electricity production(% of total) in Least developed countries in 2004 to that in 2006?
Make the answer very short. 1.01. What is the ratio of the Electricity production(% of total) of Argentina in 2004 to that in 2006?
Keep it short and to the point. 1.18. What is the ratio of the Electricity production(% of total) of Iran in 2004 to that in 2006?
Ensure brevity in your answer.  1.1. What is the ratio of the Electricity production(% of total) in Italy in 2004 to that in 2006?
Your response must be concise. 0.85. What is the ratio of the Electricity production(% of total) in Least developed countries in 2005 to that in 2006?
Ensure brevity in your answer.  1. What is the ratio of the Electricity production(% of total) of Argentina in 2005 to that in 2006?
Offer a very short reply. 1.13. What is the ratio of the Electricity production(% of total) in Iran in 2005 to that in 2006?
Offer a very short reply. 1.06. What is the ratio of the Electricity production(% of total) in Italy in 2005 to that in 2006?
Your answer should be very brief. 0.98. What is the difference between the highest and the second highest Electricity production(% of total) in Least developed countries?
Offer a very short reply. 0.23. What is the difference between the highest and the second highest Electricity production(% of total) of Argentina?
Offer a very short reply. 2.36. What is the difference between the highest and the second highest Electricity production(% of total) in Iran?
Your answer should be compact. 0.84. What is the difference between the highest and the second highest Electricity production(% of total) in Italy?
Ensure brevity in your answer.  1.09. What is the difference between the highest and the lowest Electricity production(% of total) in Least developed countries?
Give a very brief answer. 4.16. What is the difference between the highest and the lowest Electricity production(% of total) of Argentina?
Provide a short and direct response. 8.51. What is the difference between the highest and the lowest Electricity production(% of total) in Iran?
Provide a succinct answer. 7.67. What is the difference between the highest and the lowest Electricity production(% of total) in Italy?
Make the answer very short. 15.56. 